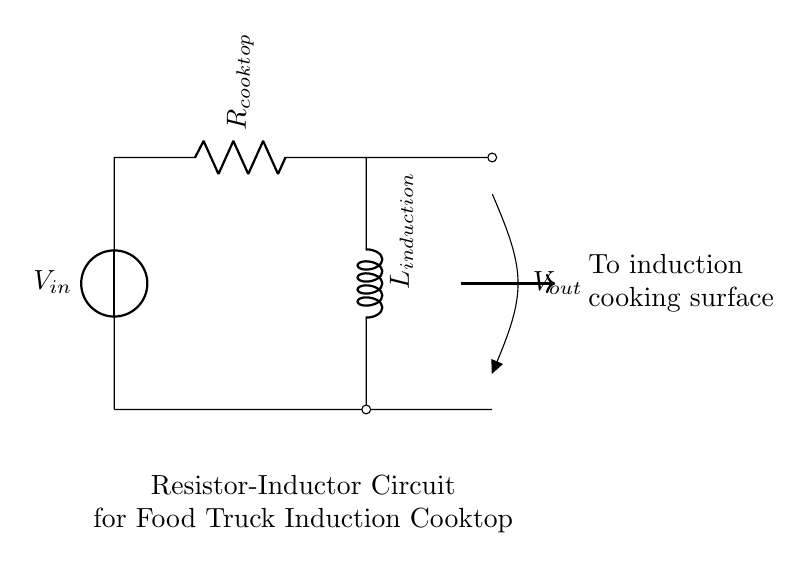what is the type of this circuit? The circuit includes a resistor and an inductor, making it a resistor-inductor circuit.
Answer: resistor-inductor what is the function of the resistor in this circuit? The resistor in this circuit regulates the current flowing through the circuit and helps manage the heat generated during Cooktop operation.
Answer: current regulation what is the voltage source in the circuit? The circuit diagram shows a voltage source labeled V in, which supplies the voltage necessary for circuit operation.
Answer: V in what happens when you increase the inductance L in the circuit? Increasing the inductance L will result in a slower rate of change of current, which can improve the efficiency of the induction heating by maintaining a consistent magnetic field.
Answer: slower current change what is the output across the cooking surface? The circuit has an output labeled V out that represents the voltage delivered to the cooking surface for induction heating.
Answer: V out how does the current behave in a resistor-inductor circuit at switch-on? When the circuit is first powered, the current rises gradually due to the inductor resisting changes in current. This leads to a lag in the current as compared to the voltage.
Answer: gradually increases what can cause overheating in a resistor-inductor circuit like this? Overheating can occur if the resistor is undersized for the current or if the inductor is saturated, leading to excessive heat generation. Adequate sizing and cooling should be maintained for proper operation.
Answer: undersized components 